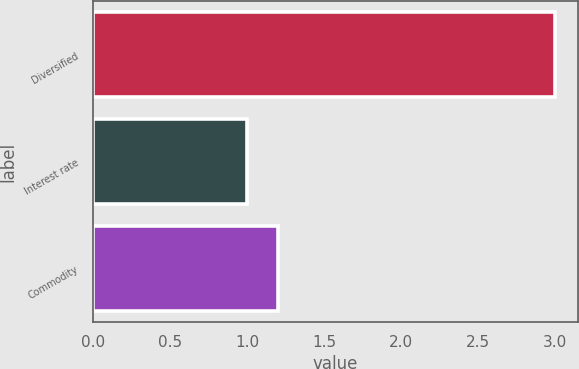Convert chart. <chart><loc_0><loc_0><loc_500><loc_500><bar_chart><fcel>Diversified<fcel>Interest rate<fcel>Commodity<nl><fcel>3<fcel>1<fcel>1.2<nl></chart> 